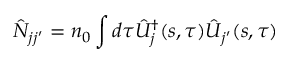Convert formula to latex. <formula><loc_0><loc_0><loc_500><loc_500>\hat { N } _ { j j ^ { \prime } } = n _ { 0 } \int d \tau \hat { U } _ { j } ^ { \dag } ( s , \tau ) \hat { U } _ { j ^ { \prime } } ( s , \tau )</formula> 